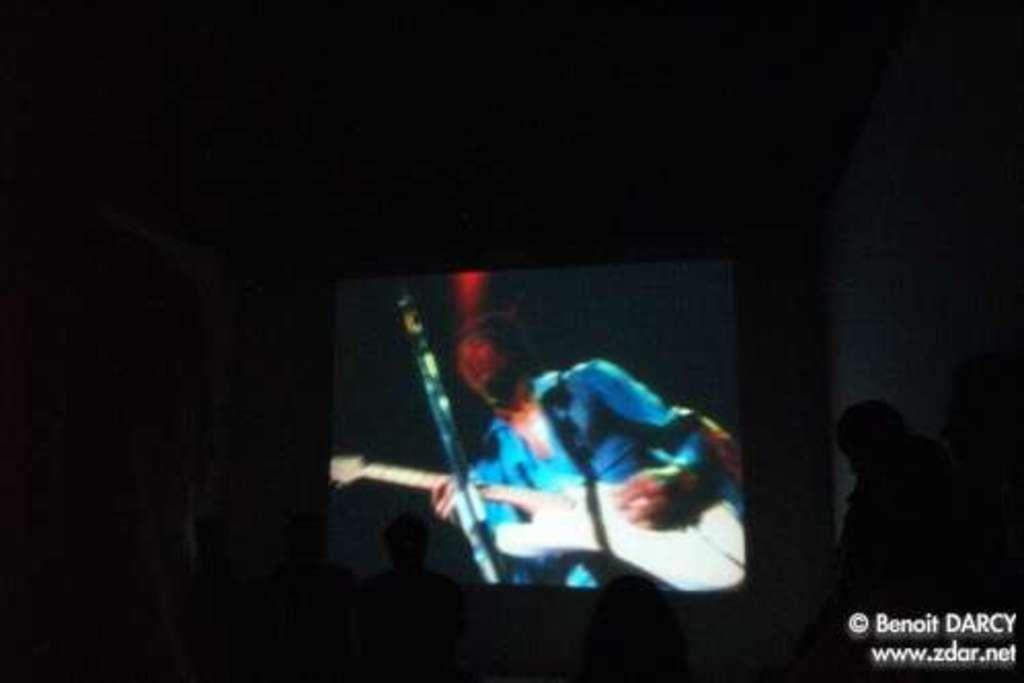What electronic device is visible in the image? There is a television in the image. Can you describe the person on the right side of the image? Unfortunately, the provided facts do not give any information about the person's appearance or actions. What is the person on the right side of the image doing? Again, the provided facts do not give any information about the person's actions. How many tents are set up in the image? There are no tents present in the image. What type of haircut does the person on the right side of the image have? There is no information about the person's haircut in the provided facts. 